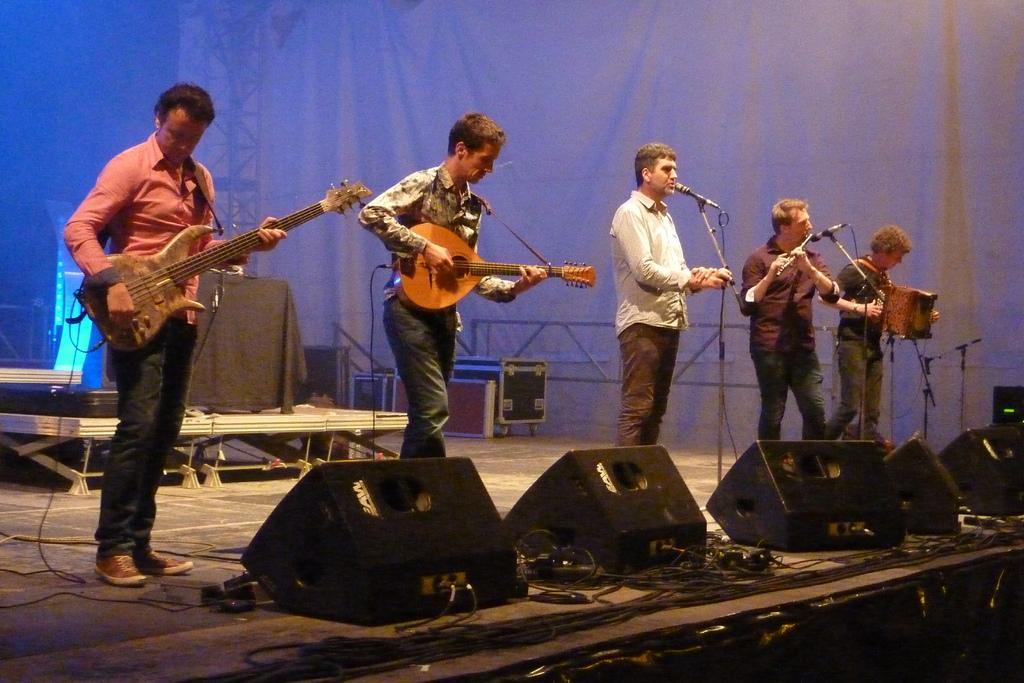How many people are playing musical instruments in the image? There are four people playing musical instruments in the image. What is the position of one person in relation to the microphone? One person is standing in front of a microphone. What color is the leaf on the governor's desk in the image? There is no leaf or governor's desk present in the image. 